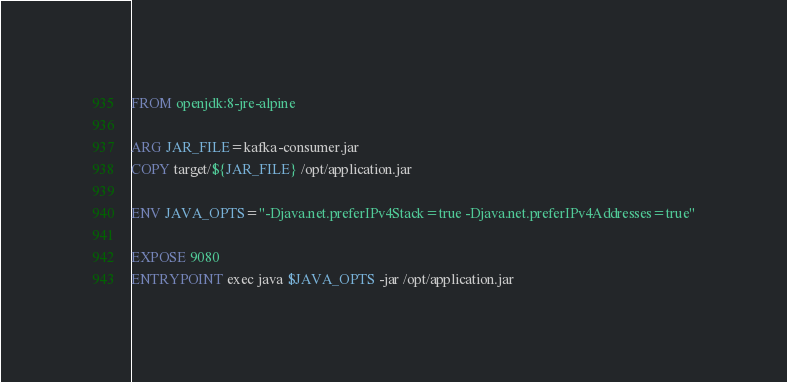<code> <loc_0><loc_0><loc_500><loc_500><_Dockerfile_>FROM openjdk:8-jre-alpine

ARG JAR_FILE=kafka-consumer.jar
COPY target/${JAR_FILE} /opt/application.jar

ENV JAVA_OPTS="-Djava.net.preferIPv4Stack=true -Djava.net.preferIPv4Addresses=true"

EXPOSE 9080
ENTRYPOINT exec java $JAVA_OPTS -jar /opt/application.jar</code> 